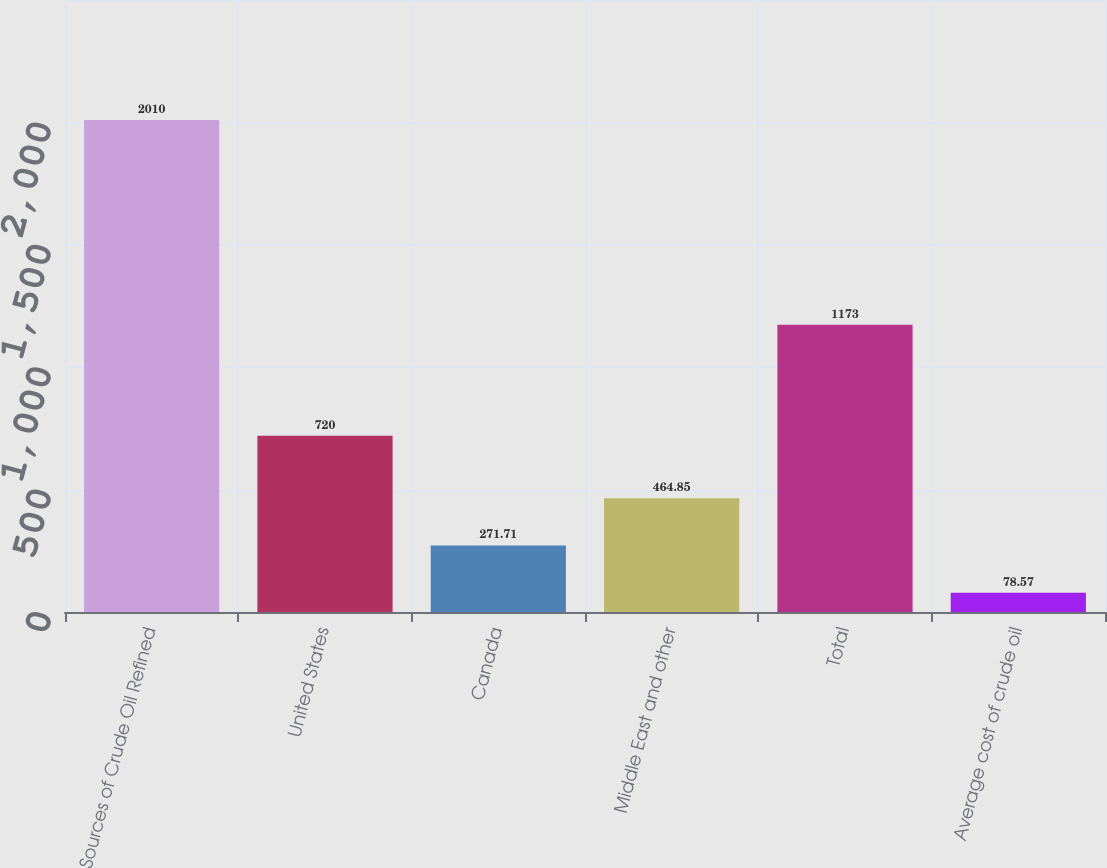Convert chart to OTSL. <chart><loc_0><loc_0><loc_500><loc_500><bar_chart><fcel>Sources of Crude Oil Refined<fcel>United States<fcel>Canada<fcel>Middle East and other<fcel>Total<fcel>Average cost of crude oil<nl><fcel>2010<fcel>720<fcel>271.71<fcel>464.85<fcel>1173<fcel>78.57<nl></chart> 